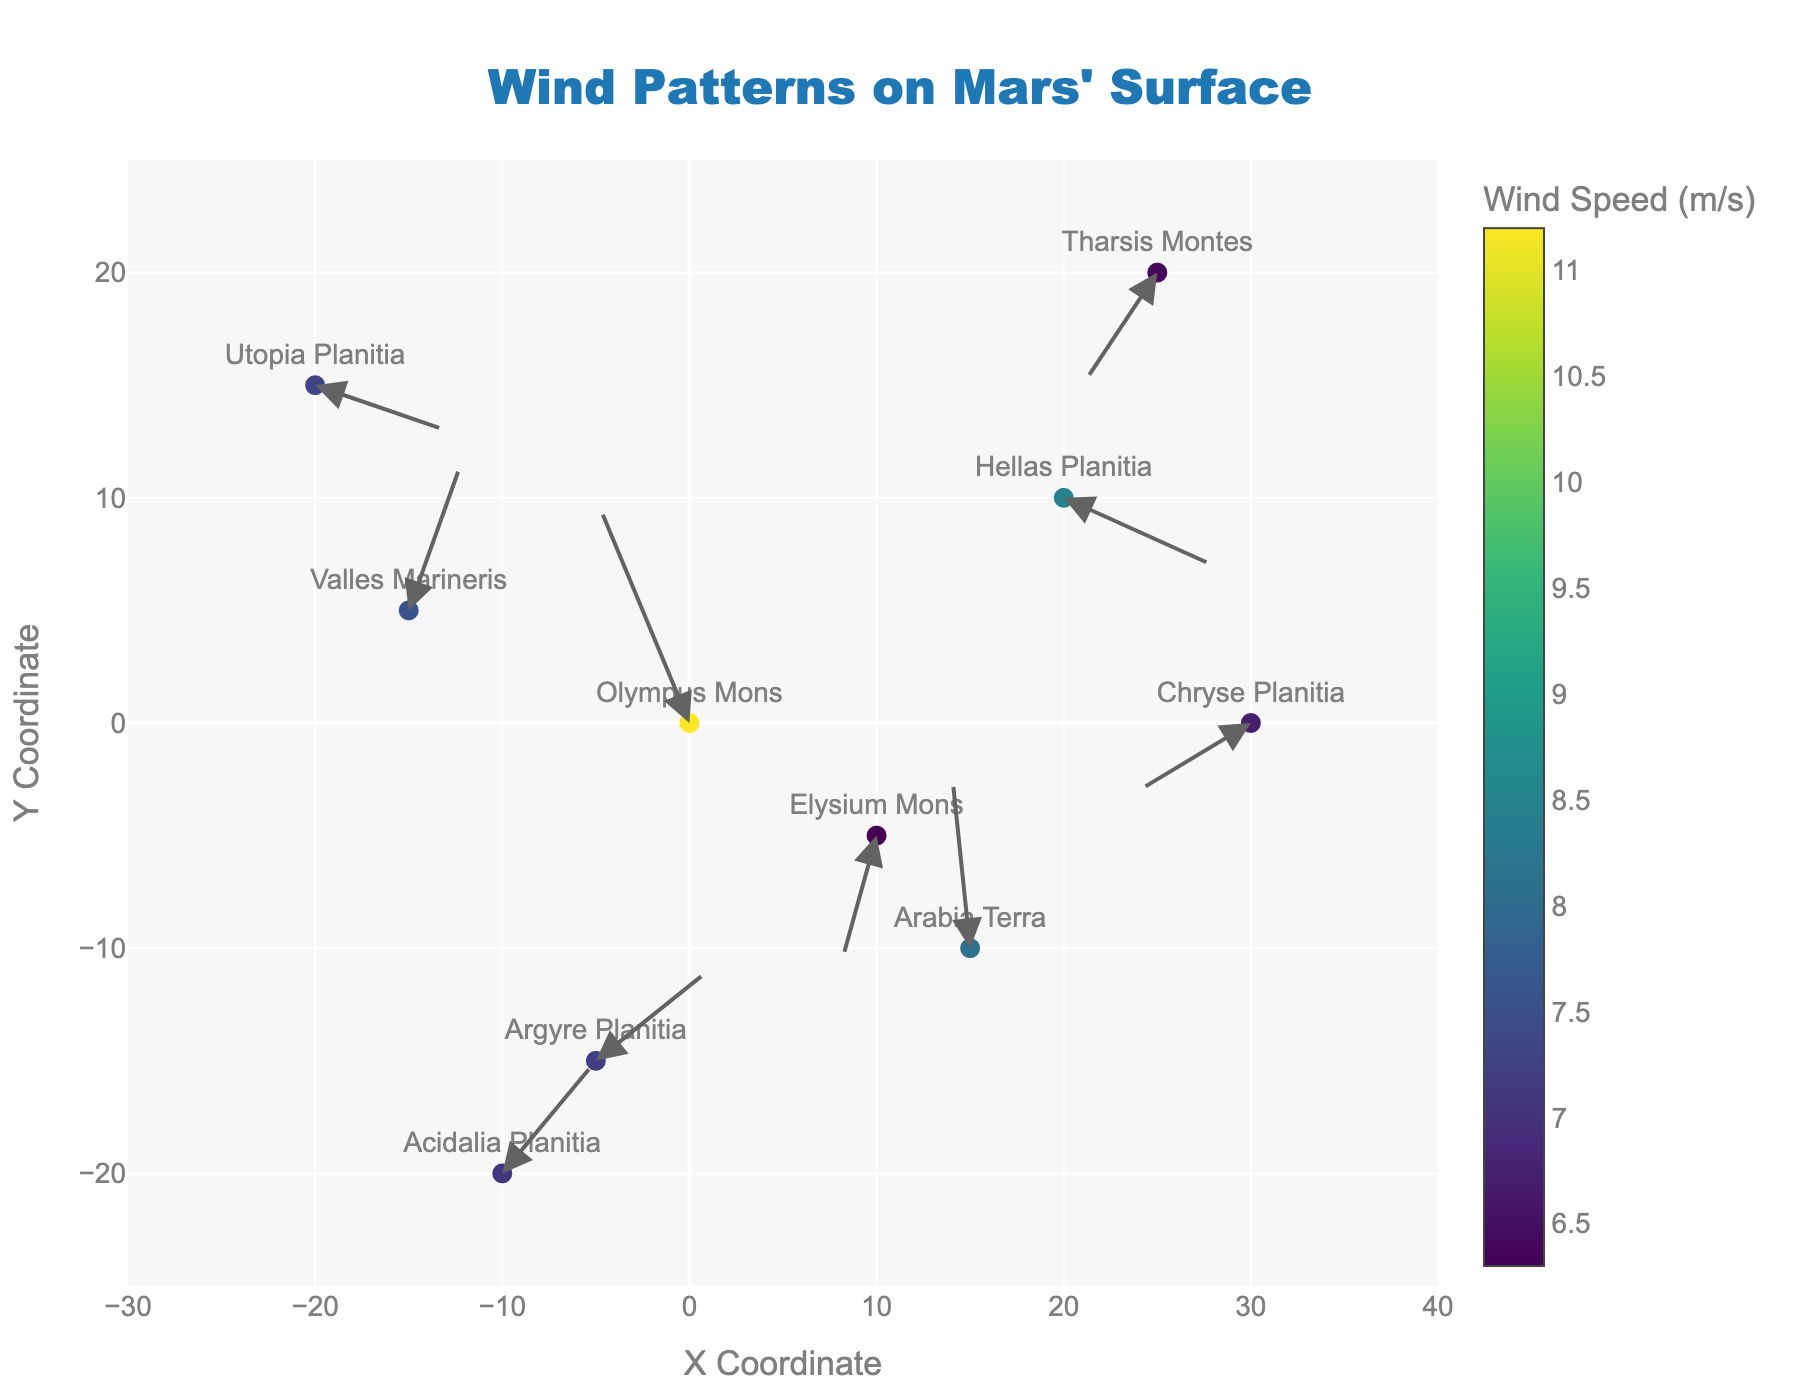What is the title of the plot? The title of the plot is typically found at the top center of the figure. It is often the largest text, distinct in color or font size, meant to give an overview of what the figure represents.
Answer: Wind Patterns on Mars' Surface What do the colors of the circles represent? The color of the circles in a quiver plot usually indicates a variable like magnitude or intensity. According to the Figure Note, the colors represent wind speed (m/s) based on a color scale shown in the figure's legend.
Answer: Wind Speed (m/s) Which location has the highest wind speed? By looking at the figure, the circle with the highest color intensity on the color scale represents the highest wind speed. The corresponding label next to it identifies the location.
Answer: Olympus Mons Which location has the lowest wind speed? The circle with the lowest color intensity on the color scale in the figure indicates the lowest wind speed. The label adjacent to it shows the location.
Answer: Elysium Mons How many data points are there in the figure? The number of data points in a quiver plot is the total number of circles or arrows. From the data provided, count the unique x, y coordinates or labeled locations.
Answer: 10 What are the coordinates of Hellas Planitia? Look for the label 'Hellas Planitia' on the figure. The coordinates are marked by its position in the x and y axes.
Answer: (20,10) Which location has the most significant eastward wind component? The eastward wind component can be determined by the arrows pointing to the right. Check for the arrow with the longest horizontal component pointing to the right, and note the corresponding label.
Answer: Utopia Planitia Which location's wind vector points in a southwest direction? A southwest direction means an arrow pointing downward and to the left. Inspect the arrows on the plot, find the southwest-pointing arrow, and locate its label.
Answer: Elysium Mons Compare the wind speed of Valles Marineris and Arabia Terra. Which is higher? Identify the colors of the circles corresponding to Valles Marineris and Arabia Terra. The darker, more intense color indicates a higher wind speed, as referred to by the color scale for wind speed.
Answer: Arabia Terra What are the individual components of the wind vector at Tharsis Montes? Locate Tharsis Montes on the plot and observe the vector's direction and magnitude. The components are given by the vector's horizontal (x) and vertical (y) parts.
Answer: (-4, -5) 